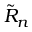<formula> <loc_0><loc_0><loc_500><loc_500>{ \tilde { R } } _ { n }</formula> 